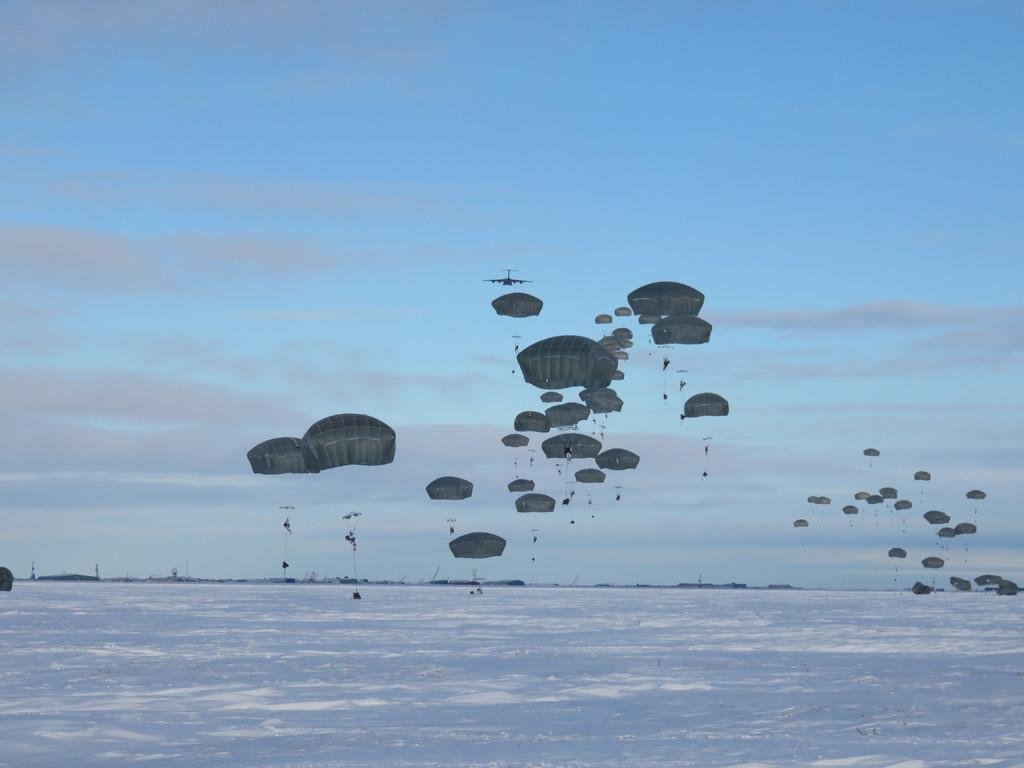What is the condition of the ground in the image? The ground is covered in snow. What is the main subject in the image? There is an airplane in the image. What else can be seen in the sky besides the airplane? There are parachutes in the air. What is visible in the background of the image? There are clouds and the sky visible in the background. What type of club does the uncle use to hit the snowball in the image? There is no uncle or snowball present in the image, so it is not possible to answer that question. 